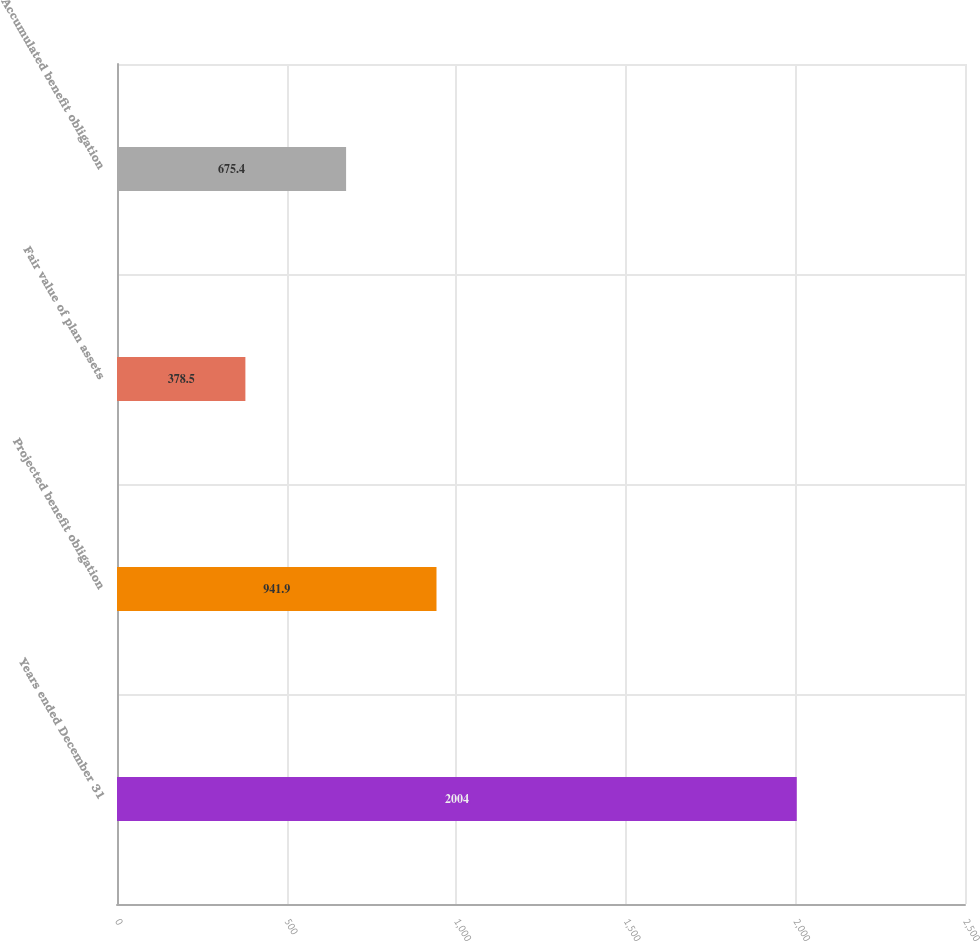Convert chart. <chart><loc_0><loc_0><loc_500><loc_500><bar_chart><fcel>Years ended December 31<fcel>Projected benefit obligation<fcel>Fair value of plan assets<fcel>Accumulated benefit obligation<nl><fcel>2004<fcel>941.9<fcel>378.5<fcel>675.4<nl></chart> 